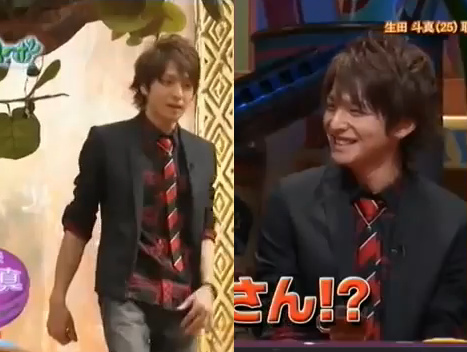What is the name of the folded article of clothing? The folded article of clothing is called a coat. 